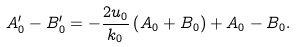Convert formula to latex. <formula><loc_0><loc_0><loc_500><loc_500>A _ { 0 } ^ { \prime } - B _ { 0 } ^ { \prime } = - \frac { 2 u _ { 0 } } { k _ { 0 } } \left ( A _ { 0 } + B _ { 0 } \right ) + A _ { 0 } - B _ { 0 } .</formula> 